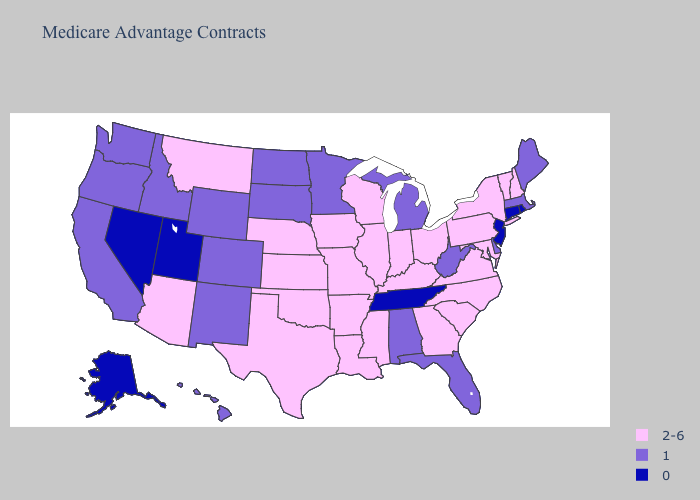Name the states that have a value in the range 1?
Keep it brief. Alabama, California, Colorado, Delaware, Florida, Hawaii, Idaho, Massachusetts, Maine, Michigan, Minnesota, North Dakota, New Mexico, Oregon, South Dakota, Washington, West Virginia, Wyoming. What is the highest value in the MidWest ?
Concise answer only. 2-6. What is the highest value in states that border Illinois?
Keep it brief. 2-6. What is the lowest value in the MidWest?
Quick response, please. 1. Does the map have missing data?
Concise answer only. No. Does Oregon have the same value as Idaho?
Keep it brief. Yes. Is the legend a continuous bar?
Give a very brief answer. No. What is the value of New Jersey?
Keep it brief. 0. Does Massachusetts have the same value as Maryland?
Write a very short answer. No. What is the value of Alabama?
Keep it brief. 1. Name the states that have a value in the range 2-6?
Answer briefly. Arkansas, Arizona, Georgia, Iowa, Illinois, Indiana, Kansas, Kentucky, Louisiana, Maryland, Missouri, Mississippi, Montana, North Carolina, Nebraska, New Hampshire, New York, Ohio, Oklahoma, Pennsylvania, South Carolina, Texas, Virginia, Vermont, Wisconsin. Name the states that have a value in the range 2-6?
Quick response, please. Arkansas, Arizona, Georgia, Iowa, Illinois, Indiana, Kansas, Kentucky, Louisiana, Maryland, Missouri, Mississippi, Montana, North Carolina, Nebraska, New Hampshire, New York, Ohio, Oklahoma, Pennsylvania, South Carolina, Texas, Virginia, Vermont, Wisconsin. Is the legend a continuous bar?
Write a very short answer. No. Name the states that have a value in the range 0?
Write a very short answer. Alaska, Connecticut, New Jersey, Nevada, Rhode Island, Tennessee, Utah. What is the highest value in the USA?
Answer briefly. 2-6. 